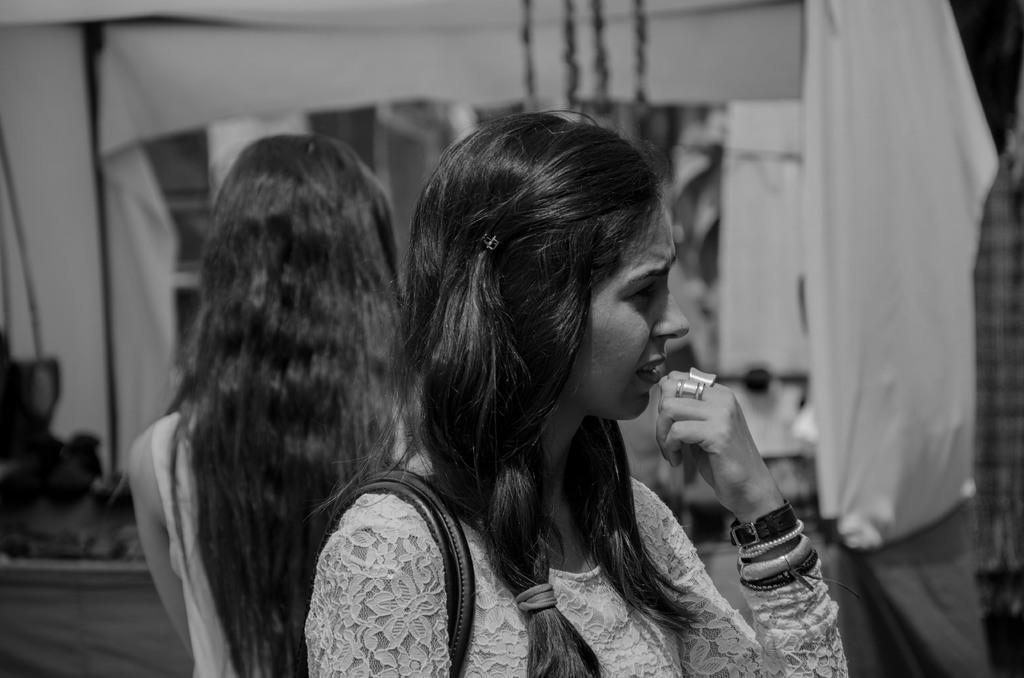Describe this image in one or two sentences. This is the picture of a lady who wore some bands to the hand and behind there is an other lady and some other things around. 